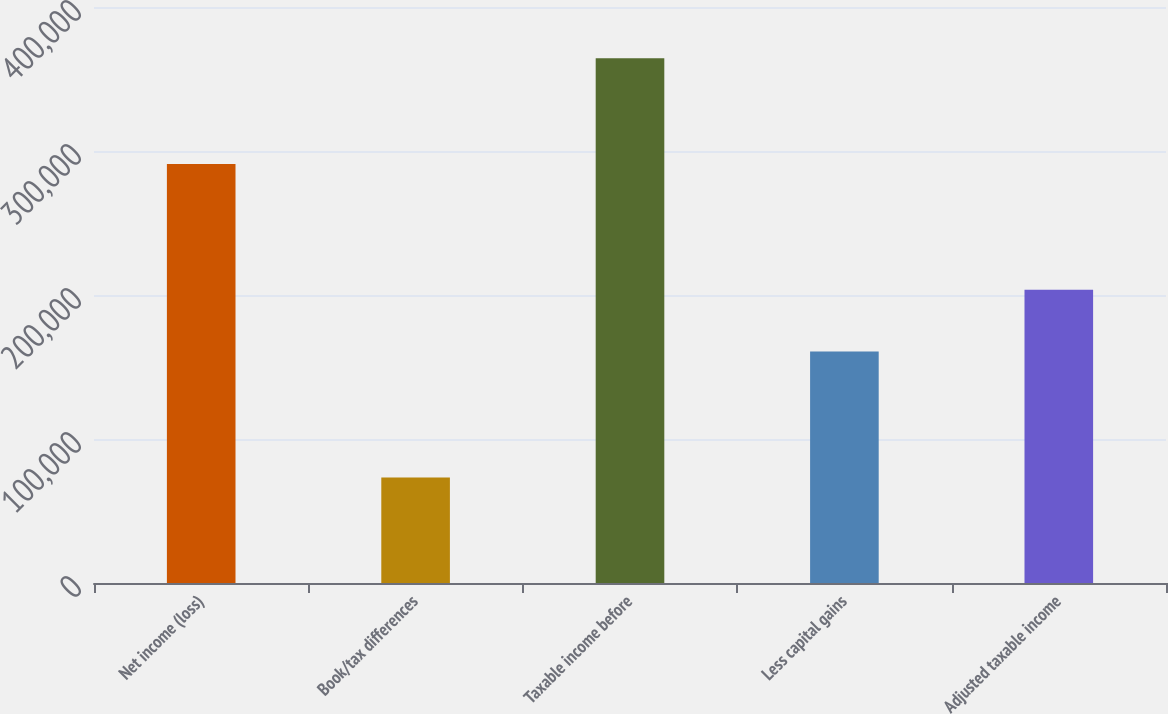Convert chart to OTSL. <chart><loc_0><loc_0><loc_500><loc_500><bar_chart><fcel>Net income (loss)<fcel>Book/tax differences<fcel>Taxable income before<fcel>Less capital gains<fcel>Adjusted taxable income<nl><fcel>291059<fcel>73322<fcel>364381<fcel>160797<fcel>203584<nl></chart> 